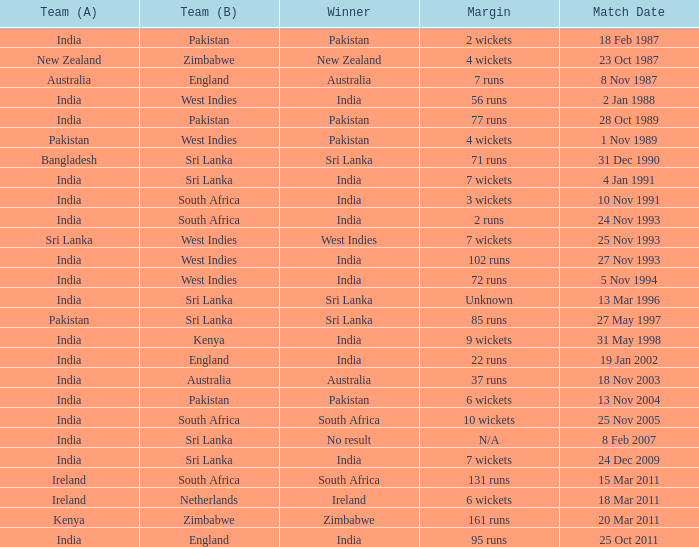Who won the match when the margin was 131 runs? South Africa. 